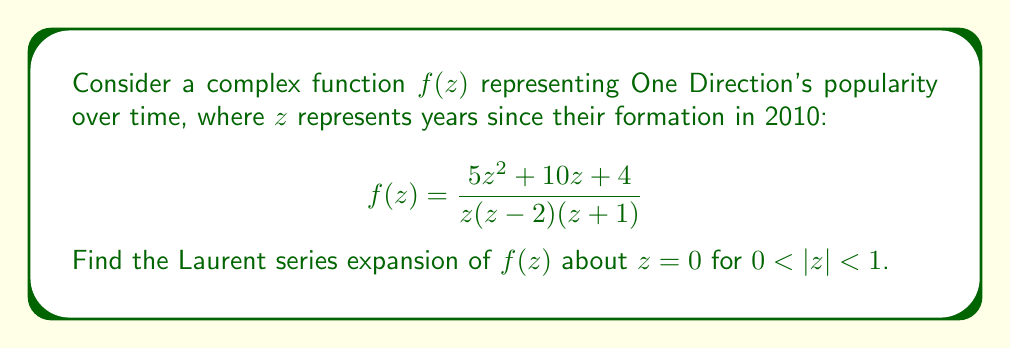Teach me how to tackle this problem. To find the Laurent series expansion of $f(z)$ about $z=0$, we need to follow these steps:

1) First, let's perform partial fraction decomposition on $f(z)$:

   $$f(z) = \frac{5z^2 + 10z + 4}{z(z-2)(z+1)} = \frac{A}{z} + \frac{B}{z-2} + \frac{C}{z+1}$$

2) Solving for A, B, and C:
   
   $A = \lim_{z \to 0} zf(z) = \frac{4}{-2} = -2$
   
   $B = \lim_{z \to 2} (z-2)f(z) = \frac{44}{6} = \frac{11}{3}$
   
   $C = \lim_{z \to -1} (z+1)f(z) = \frac{-1}{3}$

3) Now we have:

   $$f(z) = -\frac{2}{z} + \frac{11/3}{z-2} - \frac{1/3}{z+1}$$

4) For $0 < |z| < 1$, we can expand each term:

   $-\frac{2}{z}$ is already in the correct form.
   
   $\frac{11/3}{z-2} = -\frac{11/6}{1-z/2} = -\frac{11}{6}(1 + \frac{z}{2} + (\frac{z}{2})^2 + ...)$
   
   $-\frac{1/3}{z+1} = \frac{1/3}{1+z} = \frac{1}{3}(1 - z + z^2 - z^3 + ...)$

5) Combining these expansions:

   $$f(z) = -\frac{2}{z} - \frac{11}{6} - \frac{11}{12}z - \frac{11}{24}z^2 - ... + \frac{1}{3} - \frac{1}{3}z + \frac{1}{3}z^2 - \frac{1}{3}z^3 + ...$$

6) Grouping like terms:

   $$f(z) = -\frac{2}{z} - \frac{5}{2} - \frac{17}{12}z + \frac{1}{24}z^2 - \frac{1}{3}z^3 + ...$$

This is the Laurent series expansion of $f(z)$ about $z=0$ for $0 < |z| < 1$.
Answer: $$f(z) = -\frac{2}{z} - \frac{5}{2} - \frac{17}{12}z + \frac{1}{24}z^2 - \frac{1}{3}z^3 + O(z^4)$$
for $0 < |z| < 1$ 